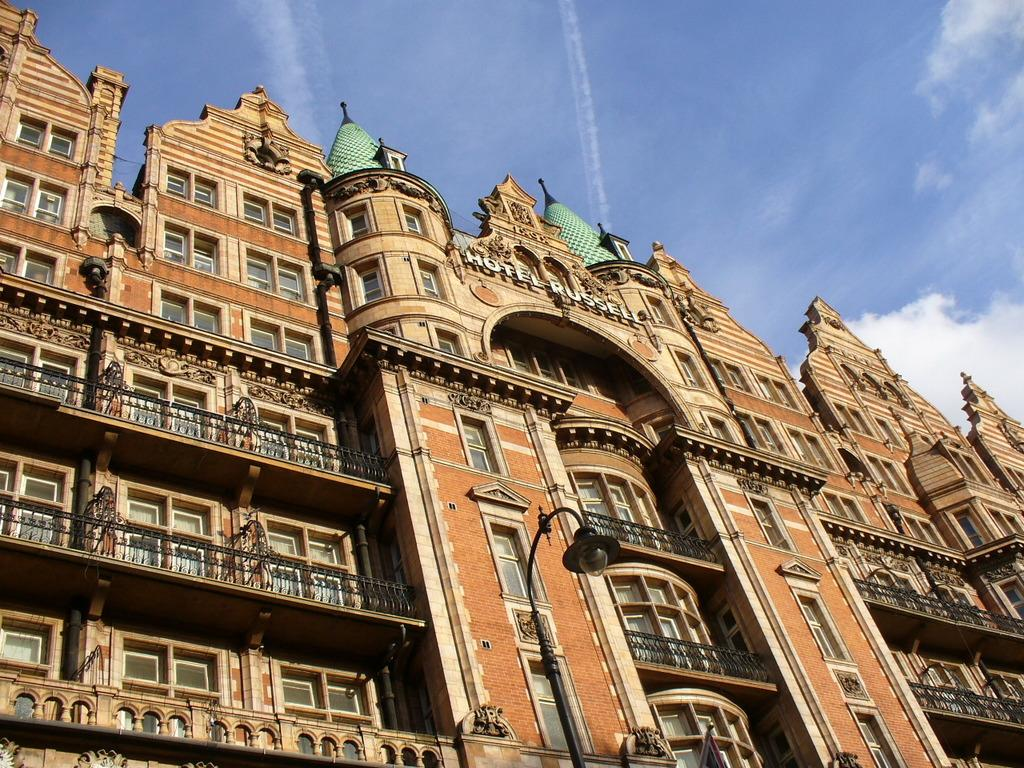What type of structure is visible in the image? There is a building in the image. What are some features of the building? The building has walls, glass windows, railings, and pipes. What can be seen in the background of the image? The sky is visible in the background of the image. Are there any other objects or structures in the image besides the building? Yes, there is a street light and a pole in the image. Where is the nest of the bird located in the image? There is no nest of a bird present in the image. What type of lumber is used to construct the building in the image? The provided facts do not mention the type of lumber used to construct the building, so it cannot be determined from the image. 